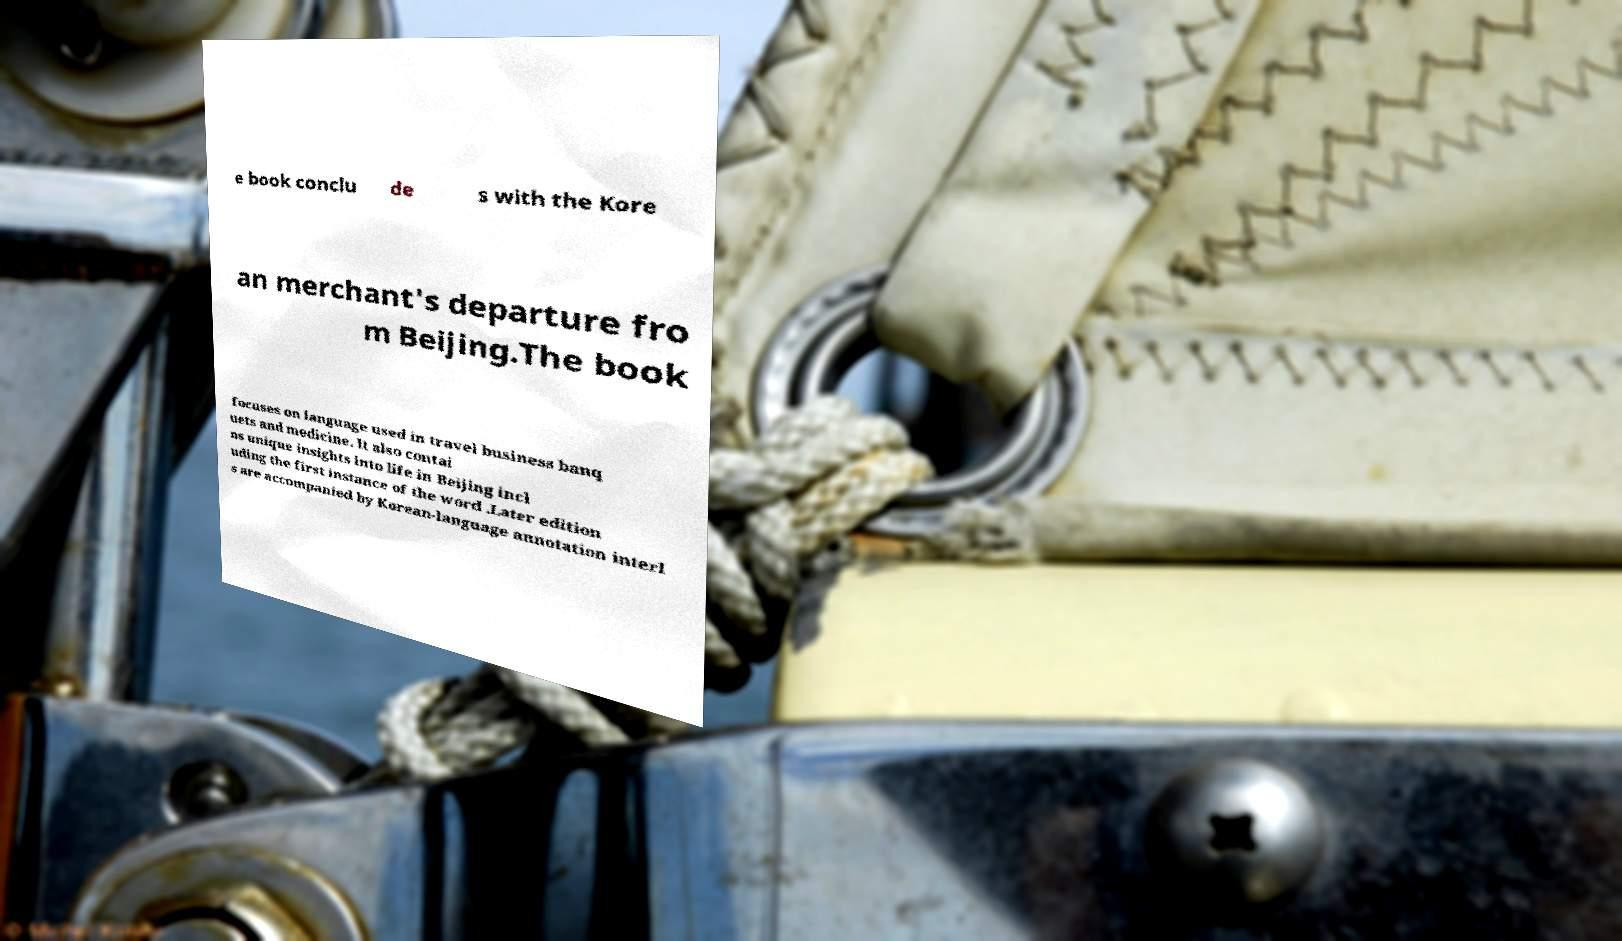For documentation purposes, I need the text within this image transcribed. Could you provide that? e book conclu de s with the Kore an merchant's departure fro m Beijing.The book focuses on language used in travel business banq uets and medicine. It also contai ns unique insights into life in Beijing incl uding the first instance of the word .Later edition s are accompanied by Korean-language annotation interl 